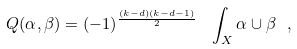<formula> <loc_0><loc_0><loc_500><loc_500>Q ( \alpha , \beta ) = ( - 1 ) ^ { \frac { ( k - d ) ( k - d - 1 ) } { 2 } } \ \int _ { X } \alpha \cup \beta \ ,</formula> 